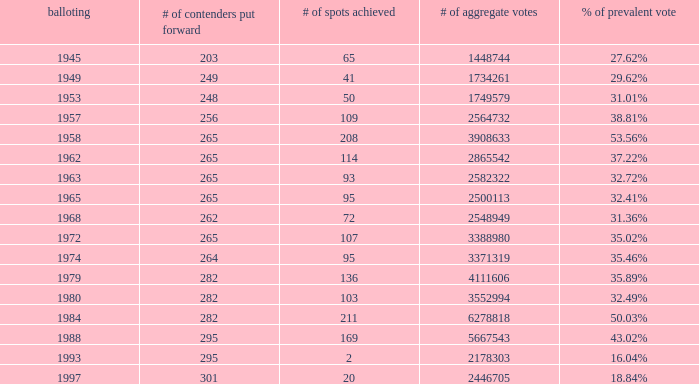How many seats were captured in the 1974 election? 95.0. 